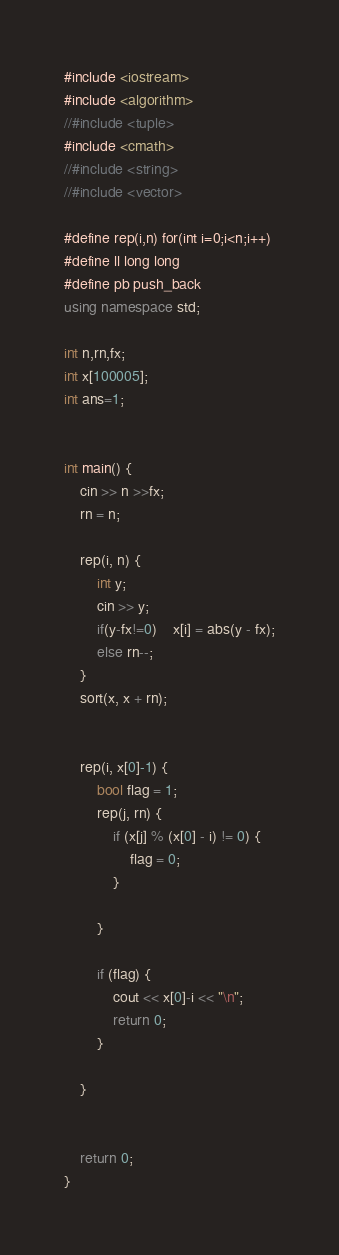Convert code to text. <code><loc_0><loc_0><loc_500><loc_500><_C++_>#include <iostream>
#include <algorithm>
//#include <tuple>
#include <cmath>
//#include <string>
//#include <vector>

#define rep(i,n) for(int i=0;i<n;i++)
#define ll long long
#define pb push_back
using namespace std;

int n,rn,fx;
int x[100005];
int ans=1;


int main() {
	cin >> n >>fx;
	rn = n;

	rep(i, n) {
		int y;
		cin >> y;
		if(y-fx!=0)	x[i] = abs(y - fx);
		else rn--;
	}
	sort(x, x + rn);

	
	rep(i, x[0]-1) {
		bool flag = 1;
		rep(j, rn) {
			if (x[j] % (x[0] - i) != 0) {
				flag = 0;
			}
		
		}
		
		if (flag) {
			cout << x[0]-i << "\n";
			return 0;
		}

	}
	

	return 0;
}
</code> 